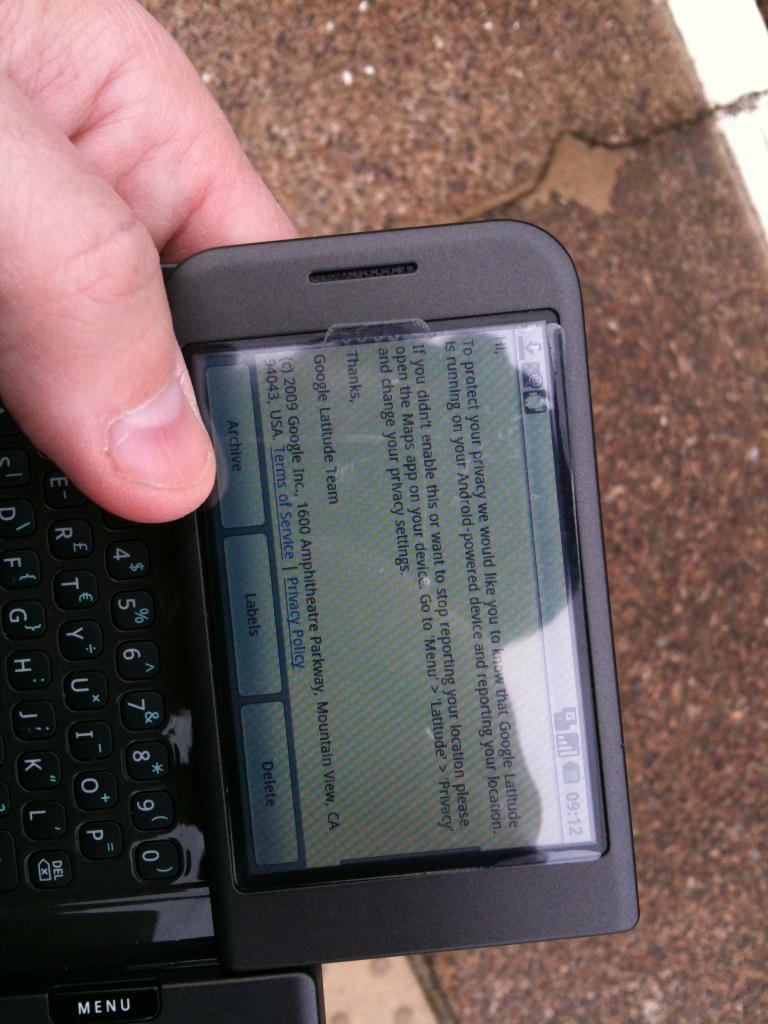<image>
Give a short and clear explanation of the subsequent image. The screen of a cellphone that reads To protect your privacy... 